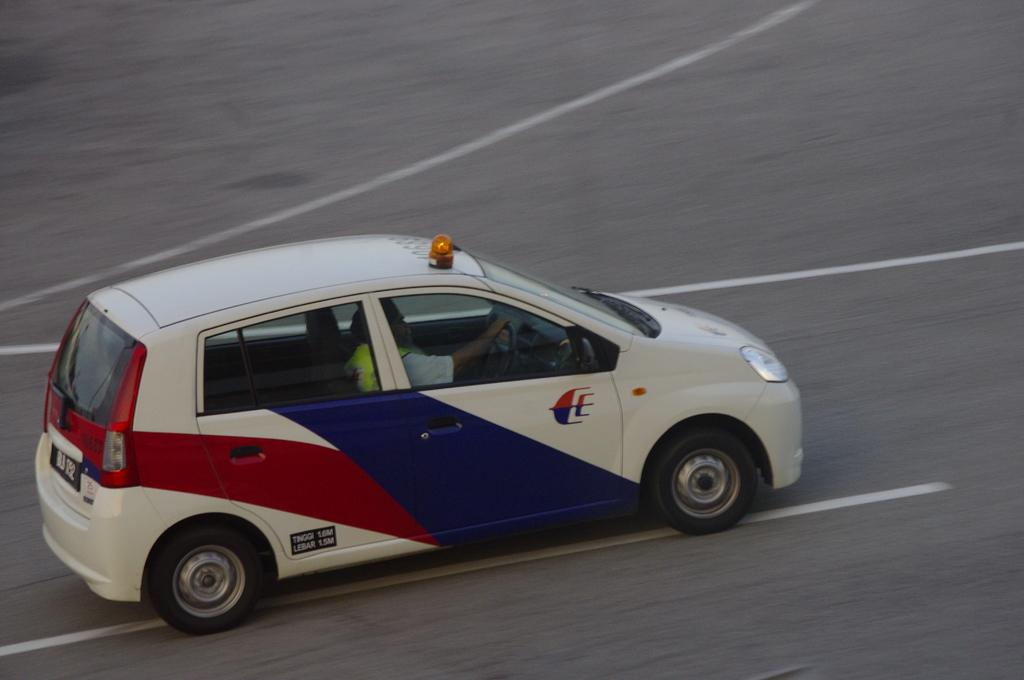What is the main subject of the image? The main subject of the image is a car. Where is the car located in the image? The car is on the road. How many clocks can be seen hanging on the car in the image? There are no clocks visible on the car in the image. What type of ducks are swimming in the pond near the car in the image? There are no ducks or pond present in the image; it only features a car on the road. 